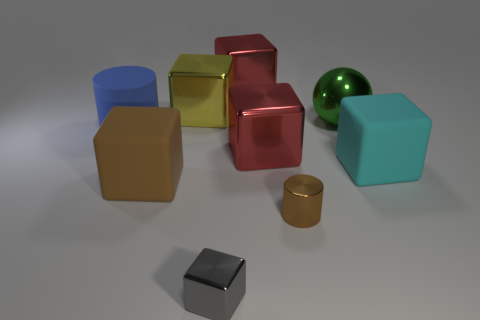There is a matte object to the right of the gray metal block; is it the same shape as the shiny object that is in front of the small brown cylinder?
Your answer should be compact. Yes. What number of rubber objects are gray blocks or big spheres?
Your answer should be very brief. 0. Is there any other thing that is the same shape as the cyan matte object?
Your answer should be very brief. Yes. What is the material of the brown object that is on the right side of the big brown object?
Provide a succinct answer. Metal. Do the large thing in front of the large cyan matte cube and the green thing have the same material?
Provide a succinct answer. No. What number of objects are tiny gray things or shiny blocks that are in front of the brown rubber block?
Keep it short and to the point. 1. There is a brown thing that is the same shape as the yellow shiny object; what size is it?
Ensure brevity in your answer.  Large. There is a large cyan matte thing; are there any blocks behind it?
Your answer should be very brief. Yes. There is a large matte cube to the left of the big shiny sphere; does it have the same color as the cylinder in front of the brown rubber block?
Ensure brevity in your answer.  Yes. Is there a brown thing that has the same shape as the cyan object?
Ensure brevity in your answer.  Yes. 